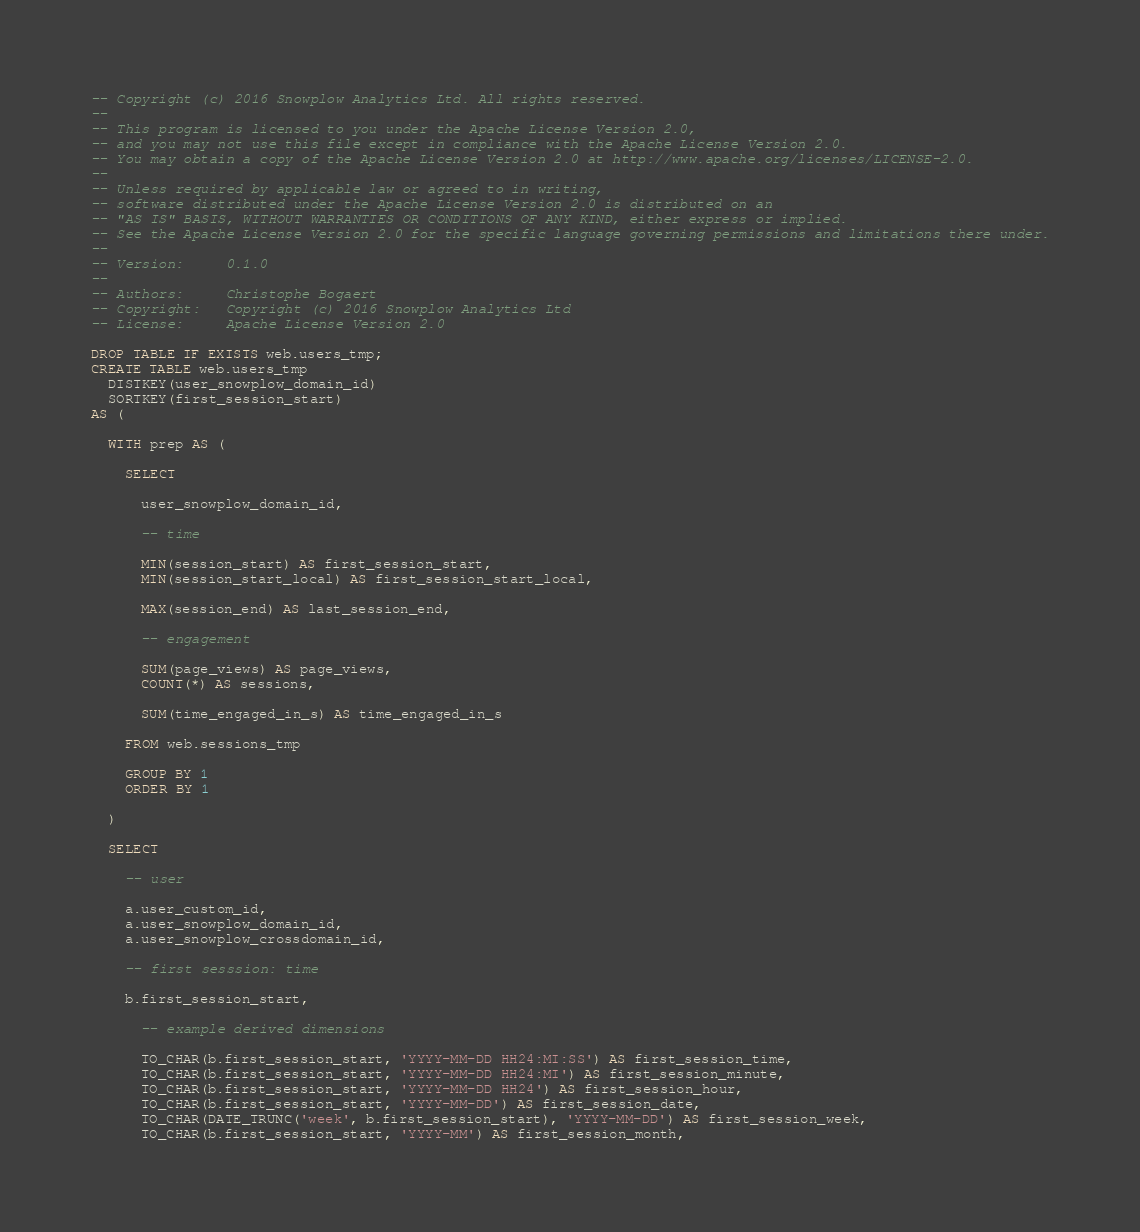Convert code to text. <code><loc_0><loc_0><loc_500><loc_500><_SQL_>-- Copyright (c) 2016 Snowplow Analytics Ltd. All rights reserved.
--
-- This program is licensed to you under the Apache License Version 2.0,
-- and you may not use this file except in compliance with the Apache License Version 2.0.
-- You may obtain a copy of the Apache License Version 2.0 at http://www.apache.org/licenses/LICENSE-2.0.
--
-- Unless required by applicable law or agreed to in writing,
-- software distributed under the Apache License Version 2.0 is distributed on an
-- "AS IS" BASIS, WITHOUT WARRANTIES OR CONDITIONS OF ANY KIND, either express or implied.
-- See the Apache License Version 2.0 for the specific language governing permissions and limitations there under.
--
-- Version:     0.1.0
--
-- Authors:     Christophe Bogaert
-- Copyright:   Copyright (c) 2016 Snowplow Analytics Ltd
-- License:     Apache License Version 2.0

DROP TABLE IF EXISTS web.users_tmp;
CREATE TABLE web.users_tmp
  DISTKEY(user_snowplow_domain_id)
  SORTKEY(first_session_start)
AS (

  WITH prep AS (

    SELECT

      user_snowplow_domain_id,

      -- time

      MIN(session_start) AS first_session_start,
      MIN(session_start_local) AS first_session_start_local,

      MAX(session_end) AS last_session_end,

      -- engagement

      SUM(page_views) AS page_views,
      COUNT(*) AS sessions,

      SUM(time_engaged_in_s) AS time_engaged_in_s

    FROM web.sessions_tmp

    GROUP BY 1
    ORDER BY 1

  )

  SELECT

    -- user

    a.user_custom_id,
    a.user_snowplow_domain_id,
    a.user_snowplow_crossdomain_id,

    -- first sesssion: time

    b.first_session_start,

      -- example derived dimensions

      TO_CHAR(b.first_session_start, 'YYYY-MM-DD HH24:MI:SS') AS first_session_time,
      TO_CHAR(b.first_session_start, 'YYYY-MM-DD HH24:MI') AS first_session_minute,
      TO_CHAR(b.first_session_start, 'YYYY-MM-DD HH24') AS first_session_hour,
      TO_CHAR(b.first_session_start, 'YYYY-MM-DD') AS first_session_date,
      TO_CHAR(DATE_TRUNC('week', b.first_session_start), 'YYYY-MM-DD') AS first_session_week,
      TO_CHAR(b.first_session_start, 'YYYY-MM') AS first_session_month,</code> 